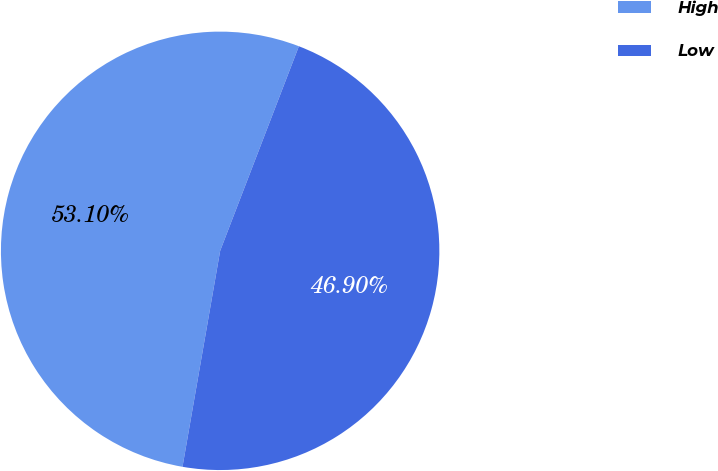<chart> <loc_0><loc_0><loc_500><loc_500><pie_chart><fcel>High<fcel>Low<nl><fcel>53.1%<fcel>46.9%<nl></chart> 